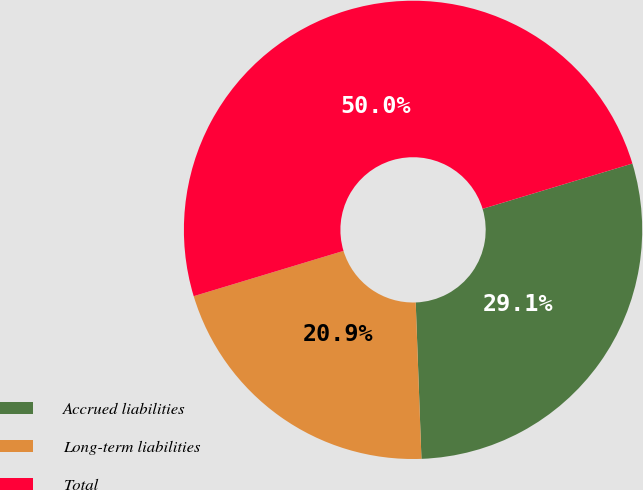Convert chart. <chart><loc_0><loc_0><loc_500><loc_500><pie_chart><fcel>Accrued liabilities<fcel>Long-term liabilities<fcel>Total<nl><fcel>29.09%<fcel>20.91%<fcel>50.0%<nl></chart> 